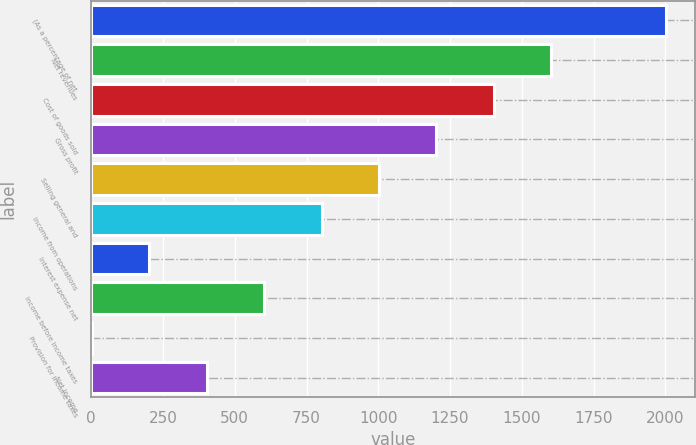Convert chart to OTSL. <chart><loc_0><loc_0><loc_500><loc_500><bar_chart><fcel>(As a percentage of net<fcel>Net revenues<fcel>Cost of goods sold<fcel>Gross profit<fcel>Selling general and<fcel>Income from operations<fcel>Interest expense net<fcel>Income before income taxes<fcel>Provision for income taxes<fcel>Net income<nl><fcel>2003<fcel>1602.74<fcel>1402.61<fcel>1202.48<fcel>1002.35<fcel>802.22<fcel>201.83<fcel>602.09<fcel>1.7<fcel>401.96<nl></chart> 